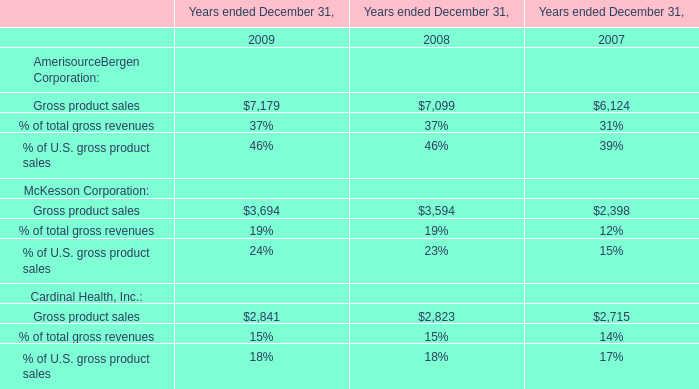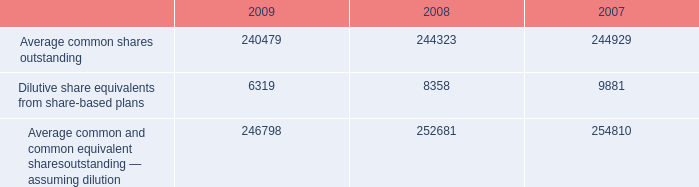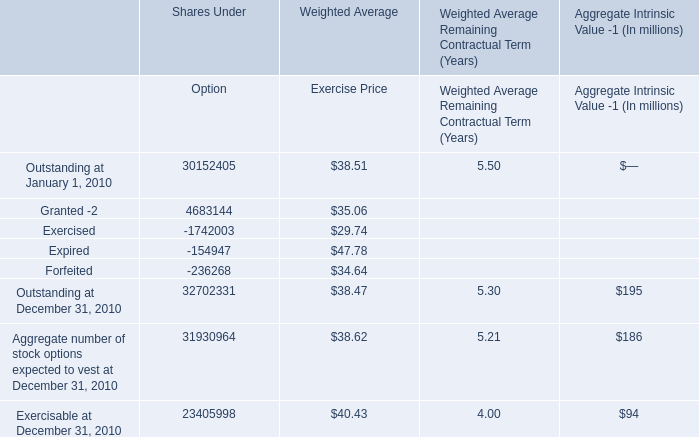What's the sum of Average common shares outstanding of 2007, and Exercised of Shares Under Option ? 
Computations: (244929.0 + 1742003.0)
Answer: 1986932.0. 